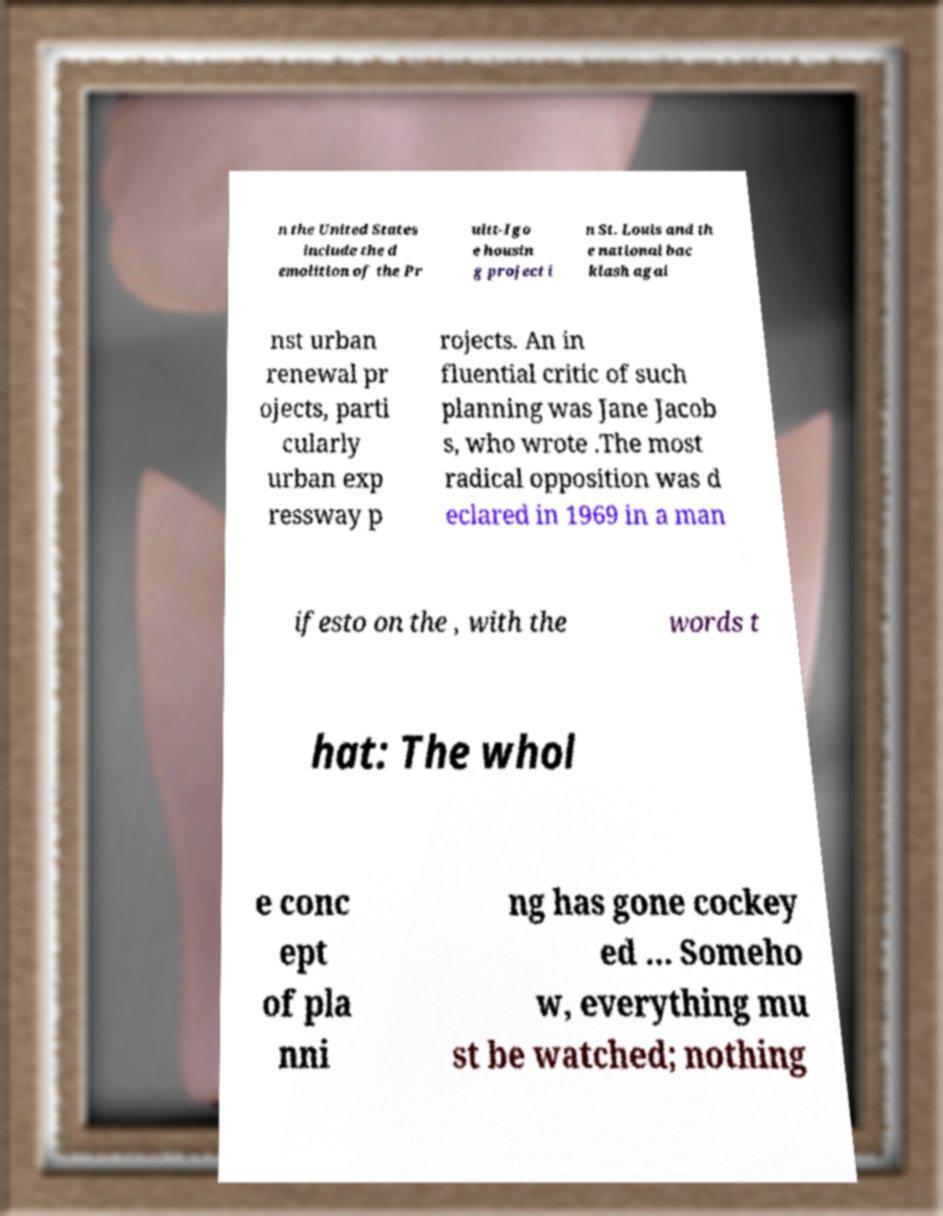What messages or text are displayed in this image? I need them in a readable, typed format. n the United States include the d emolition of the Pr uitt-Igo e housin g project i n St. Louis and th e national bac klash agai nst urban renewal pr ojects, parti cularly urban exp ressway p rojects. An in fluential critic of such planning was Jane Jacob s, who wrote .The most radical opposition was d eclared in 1969 in a man ifesto on the , with the words t hat: The whol e conc ept of pla nni ng has gone cockey ed … Someho w, everything mu st be watched; nothing 